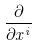<formula> <loc_0><loc_0><loc_500><loc_500>\frac { \partial } { \partial x ^ { i } }</formula> 